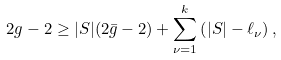Convert formula to latex. <formula><loc_0><loc_0><loc_500><loc_500>2 g - 2 \geq | S | ( 2 \bar { g } - 2 ) + \sum _ { \nu = 1 } ^ { k } \left ( | S | - \ell _ { \nu } \right ) ,</formula> 